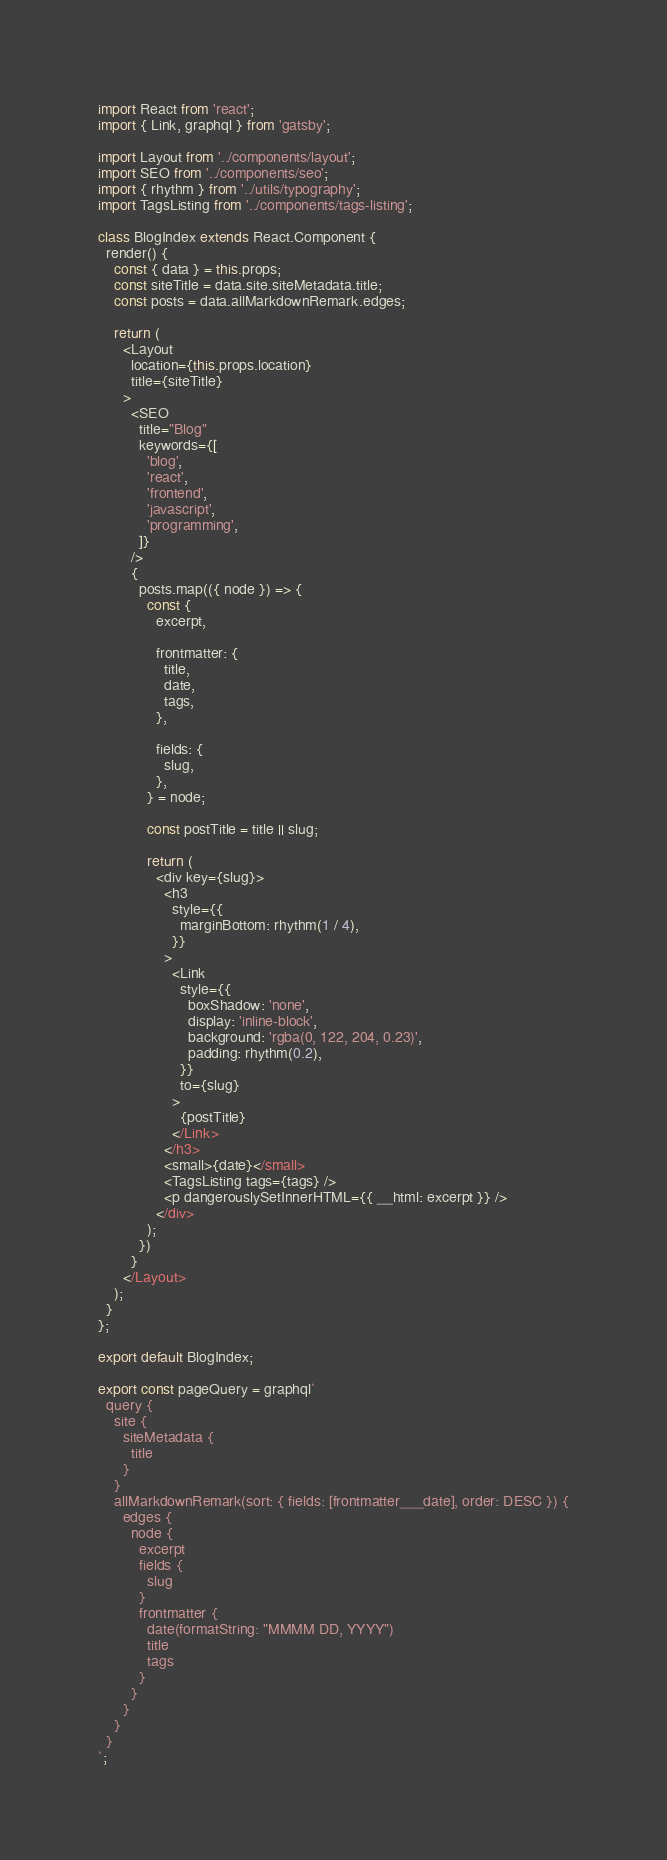Convert code to text. <code><loc_0><loc_0><loc_500><loc_500><_JavaScript_>import React from 'react';
import { Link, graphql } from 'gatsby';

import Layout from '../components/layout';
import SEO from '../components/seo';
import { rhythm } from '../utils/typography';
import TagsListing from '../components/tags-listing';

class BlogIndex extends React.Component {
  render() {
    const { data } = this.props;
    const siteTitle = data.site.siteMetadata.title;
    const posts = data.allMarkdownRemark.edges;

    return (
      <Layout
        location={this.props.location}
        title={siteTitle}
      >
        <SEO
          title="Blog"
          keywords={[
            'blog',
            'react',
            'frontend',
            'javascript',
            'programming',
          ]}
        />
        {
          posts.map(({ node }) => {
            const {
              excerpt,

              frontmatter: {
                title,
                date,
                tags,
              },

              fields: {
                slug,
              },
            } = node;

            const postTitle = title || slug;

            return (
              <div key={slug}>
                <h3
                  style={{
                    marginBottom: rhythm(1 / 4),
                  }}
                >
                  <Link
                    style={{
                      boxShadow: 'none',
                      display: 'inline-block',
                      background: 'rgba(0, 122, 204, 0.23)',
                      padding: rhythm(0.2),
                    }}
                    to={slug}
                  >
                    {postTitle}
                  </Link>
                </h3>
                <small>{date}</small>
                <TagsListing tags={tags} />
                <p dangerouslySetInnerHTML={{ __html: excerpt }} />
              </div>
            );
          })
        }
      </Layout>
    );
  }
};

export default BlogIndex;

export const pageQuery = graphql`
  query {
    site {
      siteMetadata {
        title
      }
    }
    allMarkdownRemark(sort: { fields: [frontmatter___date], order: DESC }) {
      edges {
        node {
          excerpt
          fields {
            slug
          }
          frontmatter {
            date(formatString: "MMMM DD, YYYY")
            title
            tags
          }
        }
      }
    }
  }
`;
</code> 